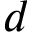Convert formula to latex. <formula><loc_0><loc_0><loc_500><loc_500>d</formula> 